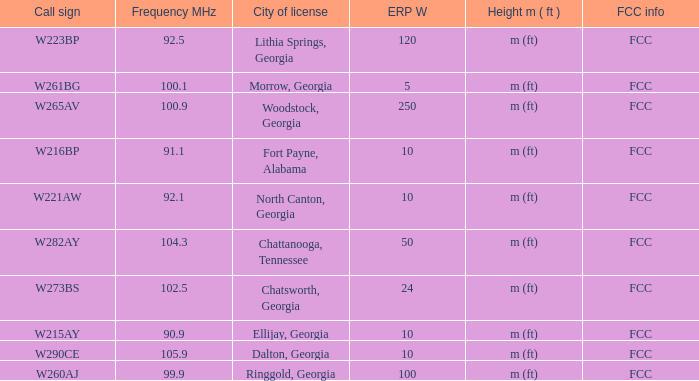What is the lowest ERP W of  w223bp? 120.0. 